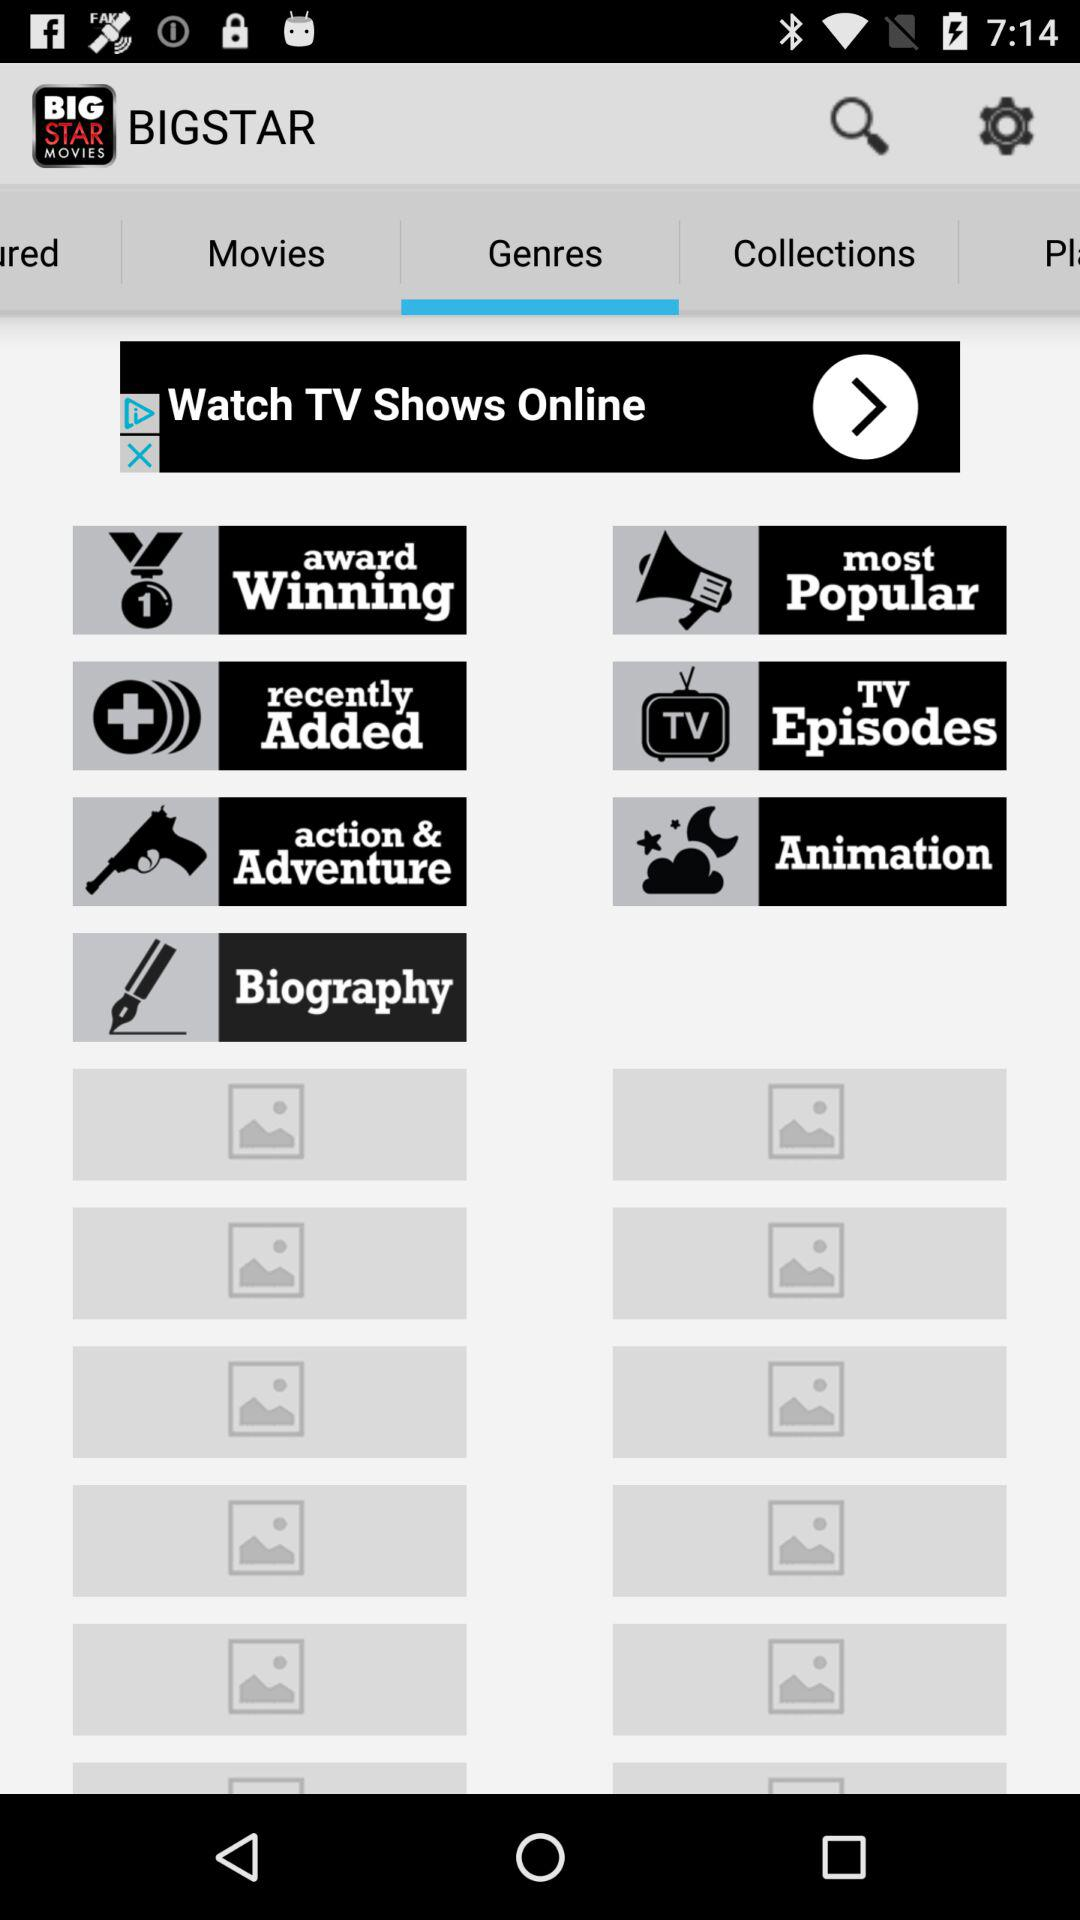Which option is selected? The selected option is "Genres". 